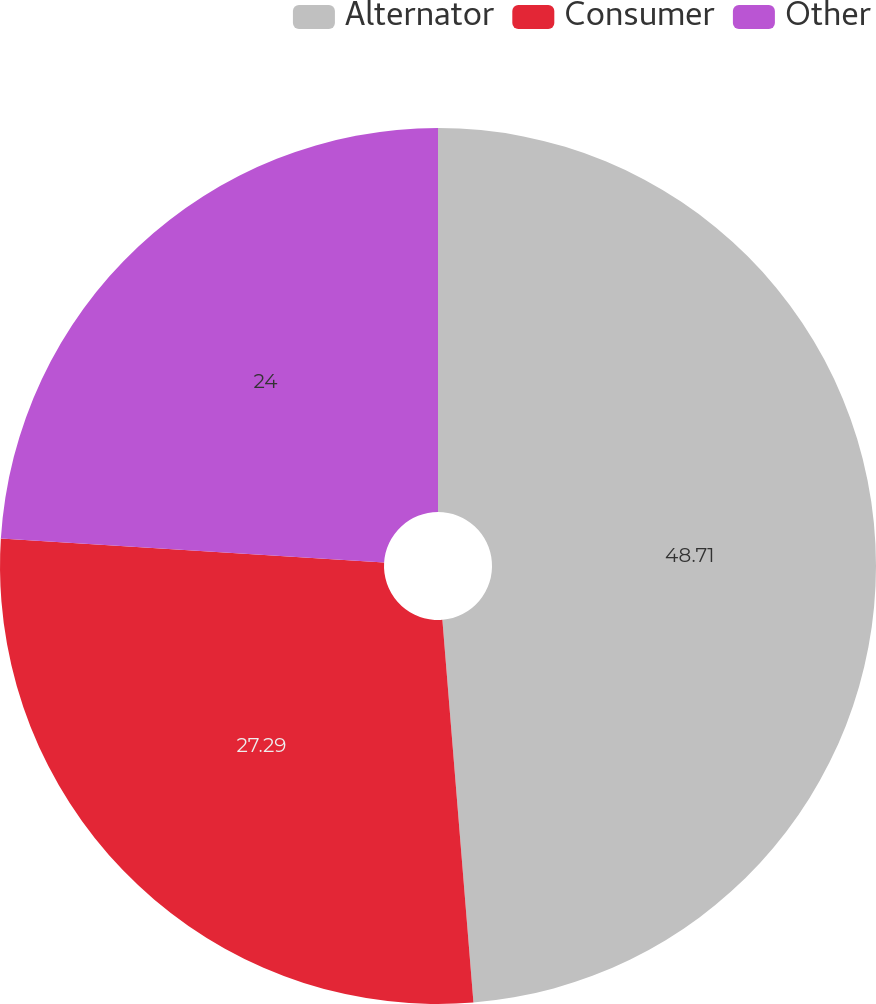Convert chart. <chart><loc_0><loc_0><loc_500><loc_500><pie_chart><fcel>Alternator<fcel>Consumer<fcel>Other<nl><fcel>48.71%<fcel>27.29%<fcel>24.0%<nl></chart> 